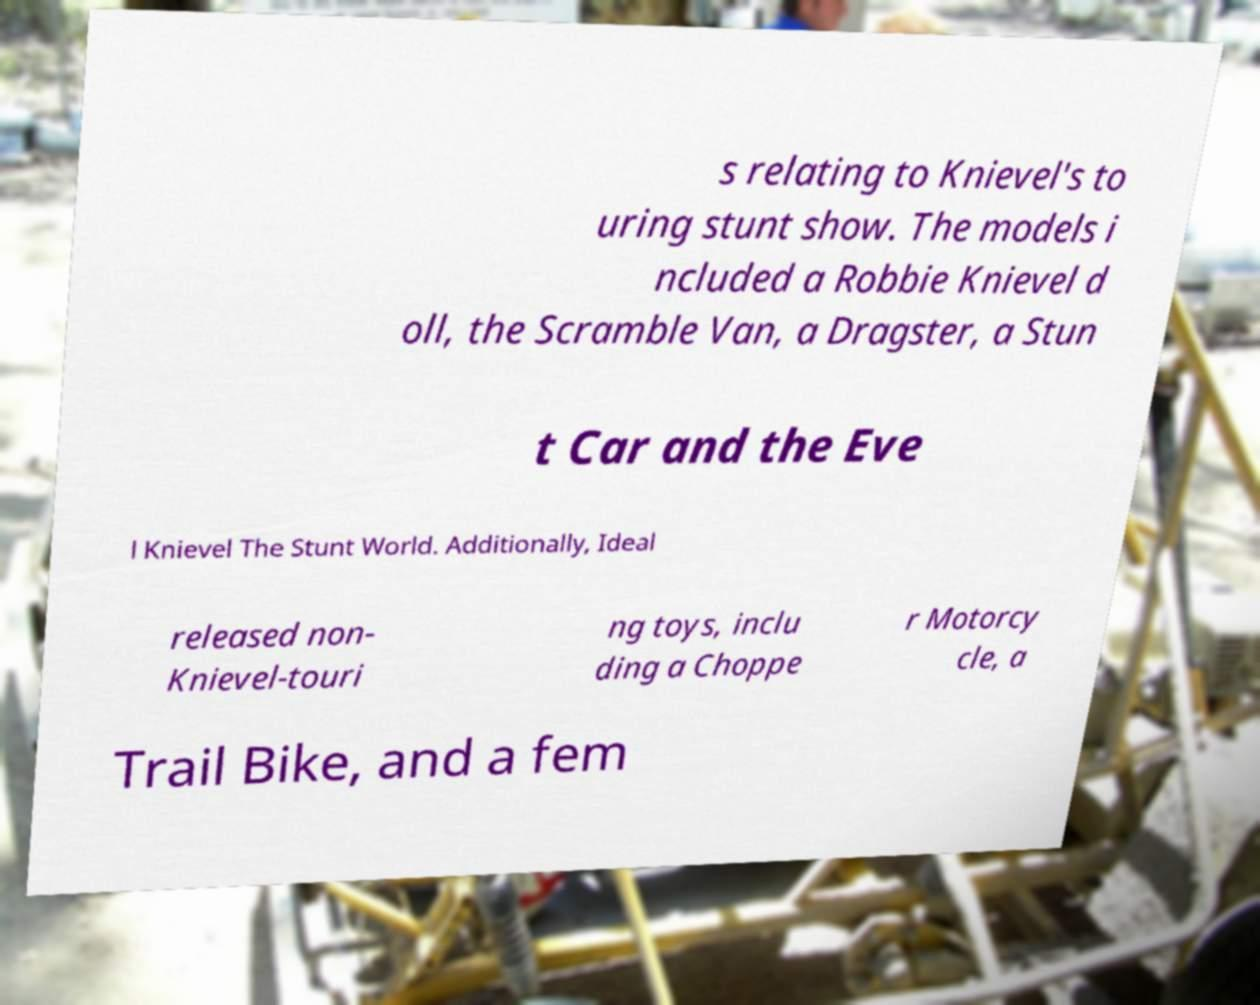There's text embedded in this image that I need extracted. Can you transcribe it verbatim? s relating to Knievel's to uring stunt show. The models i ncluded a Robbie Knievel d oll, the Scramble Van, a Dragster, a Stun t Car and the Eve l Knievel The Stunt World. Additionally, Ideal released non- Knievel-touri ng toys, inclu ding a Choppe r Motorcy cle, a Trail Bike, and a fem 